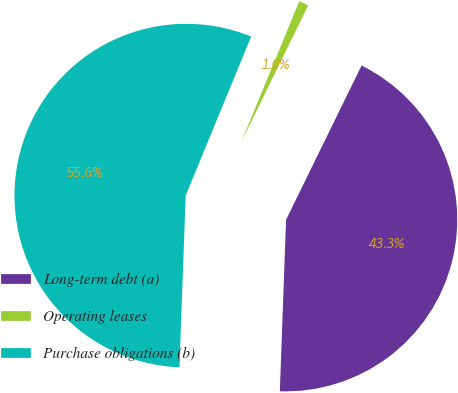Convert chart. <chart><loc_0><loc_0><loc_500><loc_500><pie_chart><fcel>Long-term debt (a)<fcel>Operating leases<fcel>Purchase obligations (b)<nl><fcel>43.33%<fcel>1.03%<fcel>55.64%<nl></chart> 